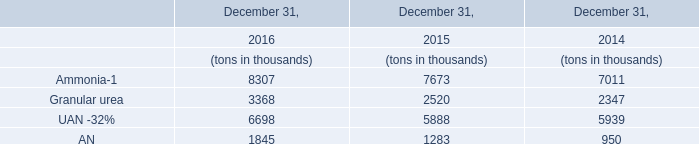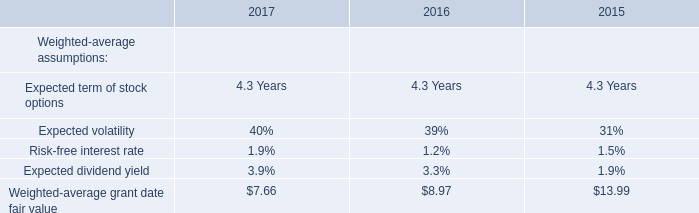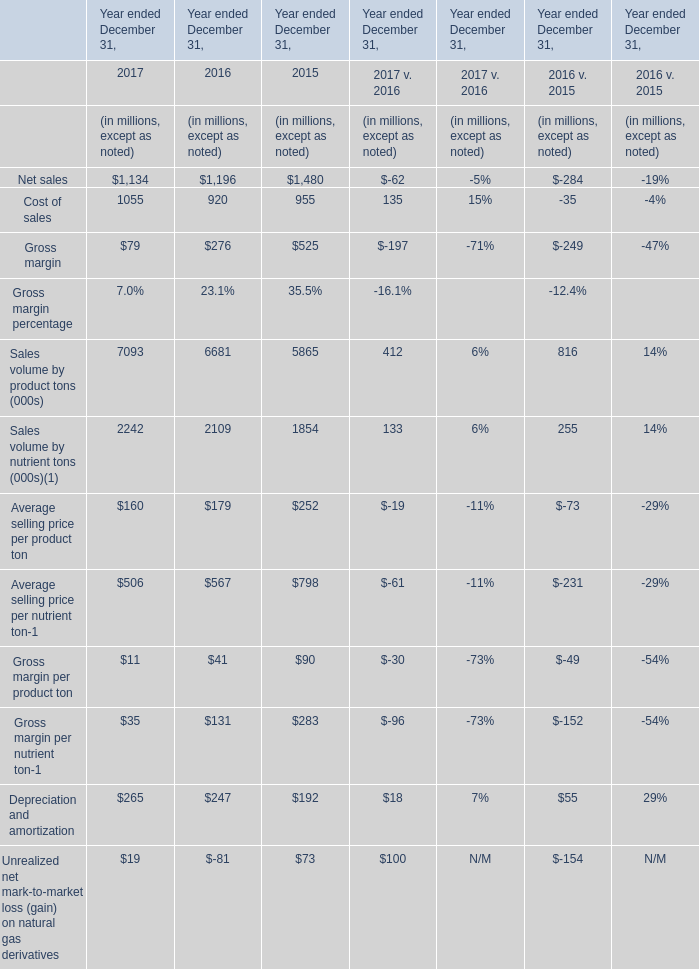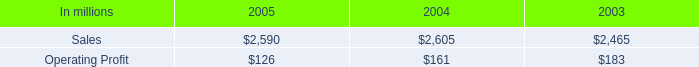What is the growing rate of Net sales in the year with the least Gross margin? 
Computations: ((1134 - 1196) / 1196)
Answer: -0.05184. 